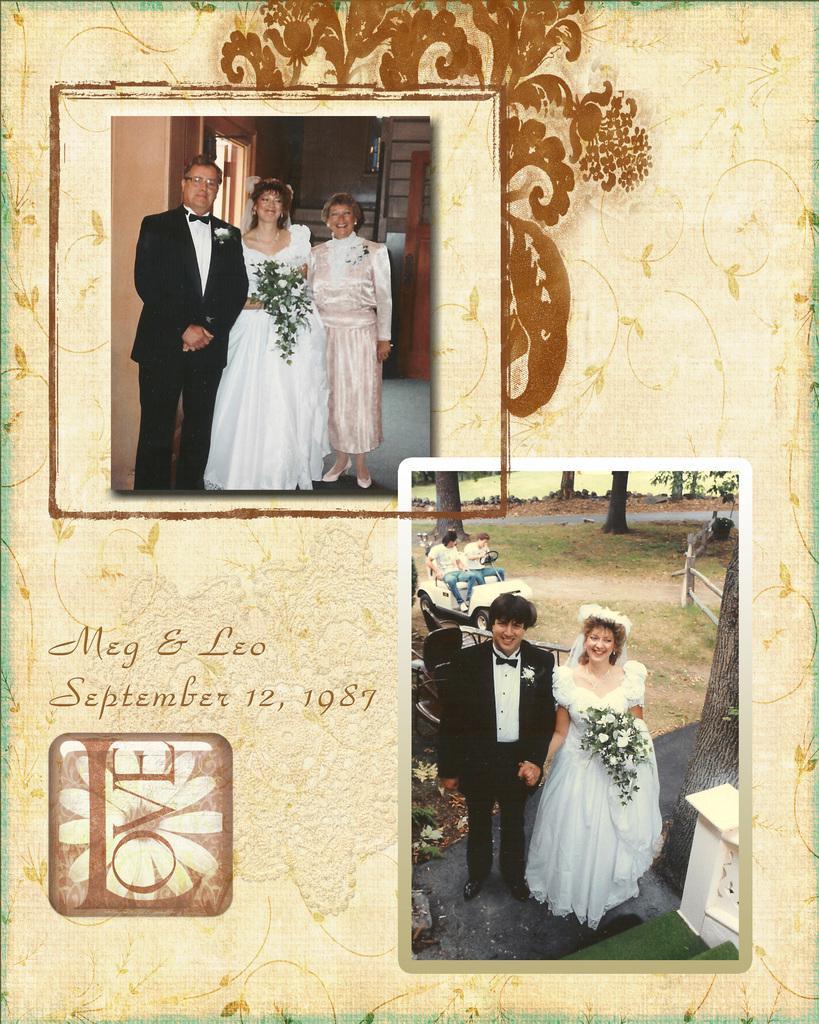How would you summarize this image in a sentence or two? In this picture we can see two college photography poster of the bride and groom standing in the front and giving a pose to the camera. 